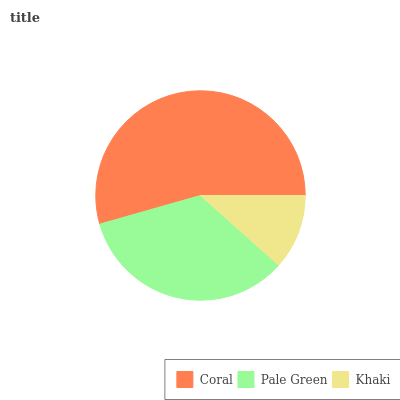Is Khaki the minimum?
Answer yes or no. Yes. Is Coral the maximum?
Answer yes or no. Yes. Is Pale Green the minimum?
Answer yes or no. No. Is Pale Green the maximum?
Answer yes or no. No. Is Coral greater than Pale Green?
Answer yes or no. Yes. Is Pale Green less than Coral?
Answer yes or no. Yes. Is Pale Green greater than Coral?
Answer yes or no. No. Is Coral less than Pale Green?
Answer yes or no. No. Is Pale Green the high median?
Answer yes or no. Yes. Is Pale Green the low median?
Answer yes or no. Yes. Is Khaki the high median?
Answer yes or no. No. Is Khaki the low median?
Answer yes or no. No. 